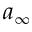Convert formula to latex. <formula><loc_0><loc_0><loc_500><loc_500>a _ { \infty }</formula> 